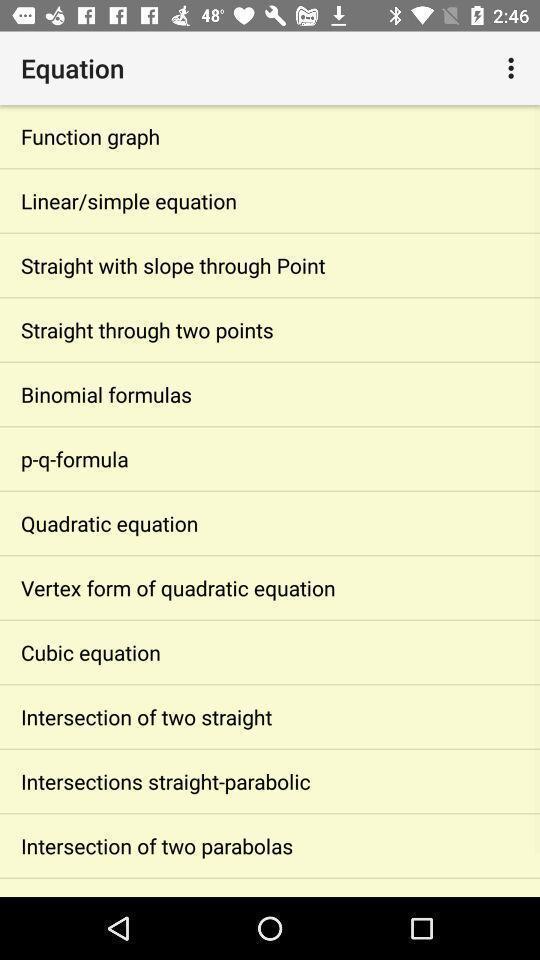Summarize the main components in this picture. Page with list of different formula options. 